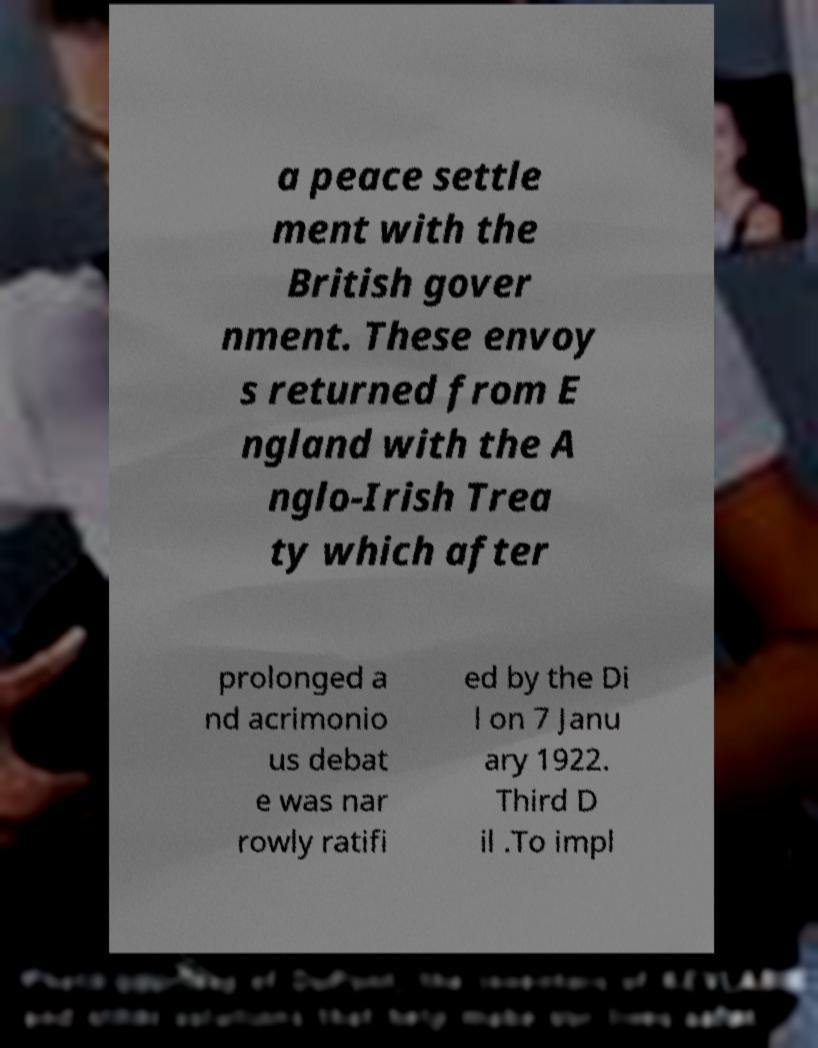Can you read and provide the text displayed in the image?This photo seems to have some interesting text. Can you extract and type it out for me? a peace settle ment with the British gover nment. These envoy s returned from E ngland with the A nglo-Irish Trea ty which after prolonged a nd acrimonio us debat e was nar rowly ratifi ed by the Di l on 7 Janu ary 1922. Third D il .To impl 